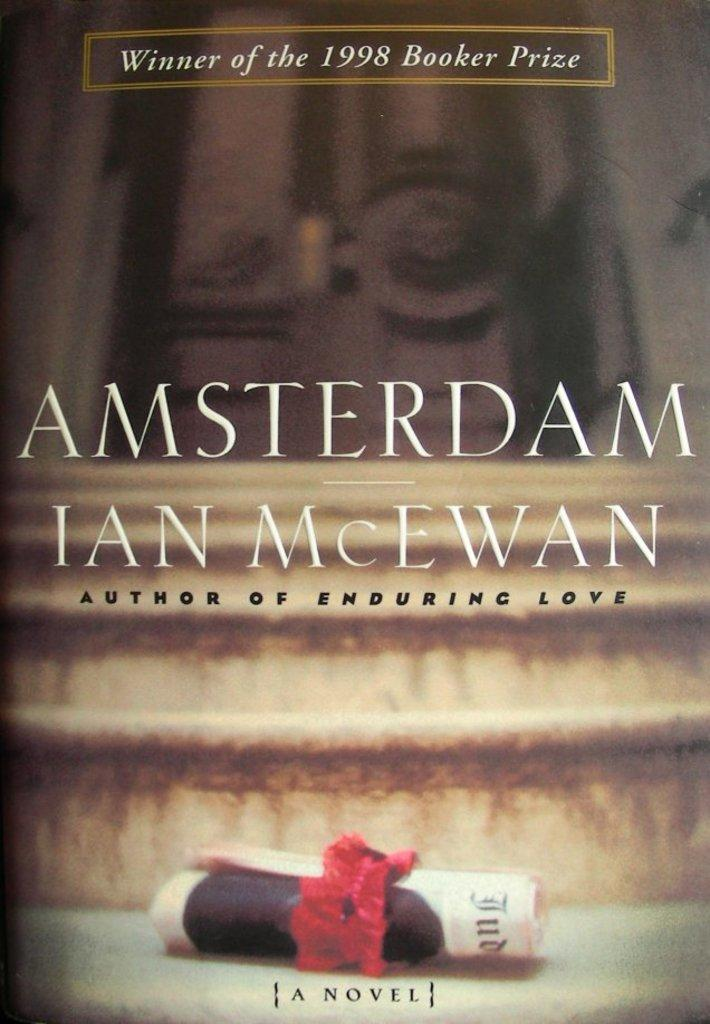What is featured on the poster in the image? There is a poster with text in the image. Where is the paper roll located in the image? The paper roll is on the stairs in the image. What type of structure can be seen in the image? There is a door in the image. What type of cent can be seen crawling on the poster in the image? There are no centipedes or any other creatures present in the image. 